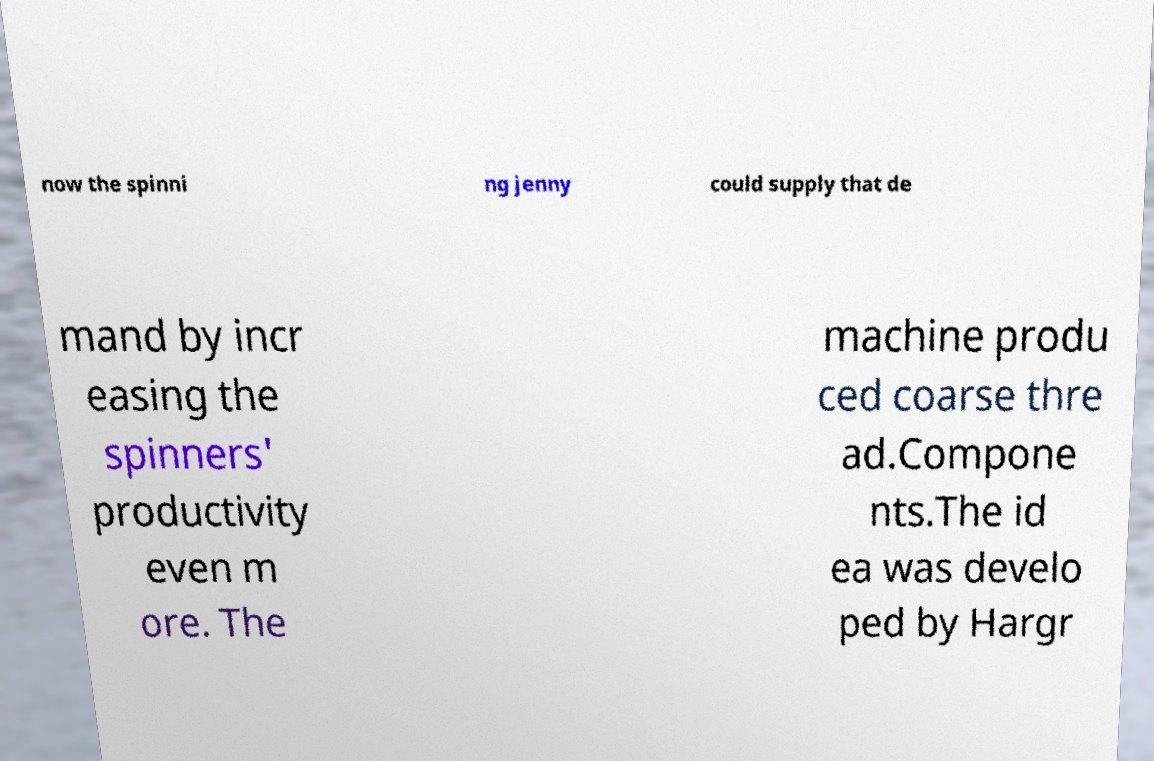What messages or text are displayed in this image? I need them in a readable, typed format. now the spinni ng jenny could supply that de mand by incr easing the spinners' productivity even m ore. The machine produ ced coarse thre ad.Compone nts.The id ea was develo ped by Hargr 